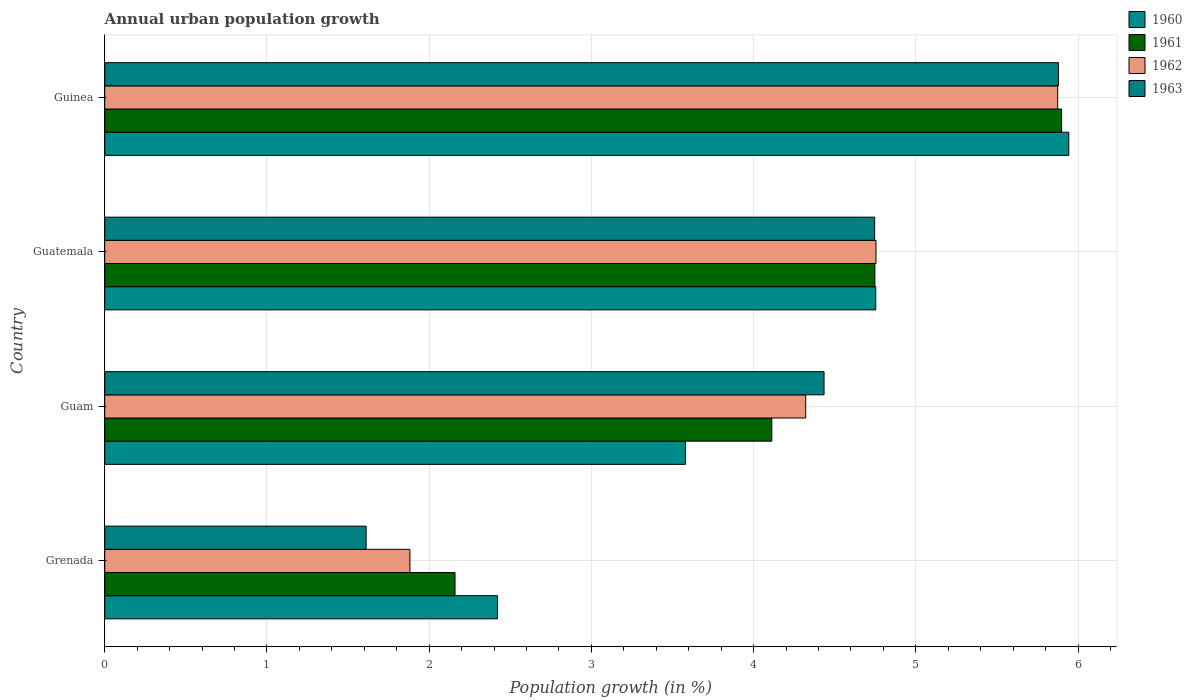How many different coloured bars are there?
Make the answer very short. 4. How many groups of bars are there?
Offer a very short reply. 4. Are the number of bars on each tick of the Y-axis equal?
Your response must be concise. Yes. How many bars are there on the 4th tick from the bottom?
Ensure brevity in your answer.  4. What is the label of the 2nd group of bars from the top?
Your answer should be compact. Guatemala. In how many cases, is the number of bars for a given country not equal to the number of legend labels?
Make the answer very short. 0. What is the percentage of urban population growth in 1963 in Grenada?
Provide a short and direct response. 1.61. Across all countries, what is the maximum percentage of urban population growth in 1960?
Your answer should be very brief. 5.94. Across all countries, what is the minimum percentage of urban population growth in 1960?
Keep it short and to the point. 2.42. In which country was the percentage of urban population growth in 1961 maximum?
Provide a short and direct response. Guinea. In which country was the percentage of urban population growth in 1960 minimum?
Provide a short and direct response. Grenada. What is the total percentage of urban population growth in 1961 in the graph?
Give a very brief answer. 16.92. What is the difference between the percentage of urban population growth in 1963 in Grenada and that in Guatemala?
Provide a succinct answer. -3.13. What is the difference between the percentage of urban population growth in 1963 in Grenada and the percentage of urban population growth in 1961 in Guam?
Ensure brevity in your answer.  -2.5. What is the average percentage of urban population growth in 1961 per country?
Keep it short and to the point. 4.23. What is the difference between the percentage of urban population growth in 1960 and percentage of urban population growth in 1961 in Guam?
Your answer should be very brief. -0.53. In how many countries, is the percentage of urban population growth in 1962 greater than 1.2 %?
Keep it short and to the point. 4. What is the ratio of the percentage of urban population growth in 1963 in Guam to that in Guinea?
Provide a short and direct response. 0.75. What is the difference between the highest and the second highest percentage of urban population growth in 1963?
Ensure brevity in your answer.  1.13. What is the difference between the highest and the lowest percentage of urban population growth in 1960?
Your answer should be very brief. 3.52. In how many countries, is the percentage of urban population growth in 1962 greater than the average percentage of urban population growth in 1962 taken over all countries?
Your response must be concise. 3. Is it the case that in every country, the sum of the percentage of urban population growth in 1960 and percentage of urban population growth in 1962 is greater than the sum of percentage of urban population growth in 1961 and percentage of urban population growth in 1963?
Make the answer very short. No. What does the 4th bar from the top in Guam represents?
Provide a short and direct response. 1960. Is it the case that in every country, the sum of the percentage of urban population growth in 1962 and percentage of urban population growth in 1960 is greater than the percentage of urban population growth in 1961?
Provide a short and direct response. Yes. How many bars are there?
Your answer should be very brief. 16. Are all the bars in the graph horizontal?
Keep it short and to the point. Yes. What is the difference between two consecutive major ticks on the X-axis?
Your answer should be compact. 1. Does the graph contain any zero values?
Your response must be concise. No. Does the graph contain grids?
Make the answer very short. Yes. What is the title of the graph?
Your response must be concise. Annual urban population growth. What is the label or title of the X-axis?
Your answer should be very brief. Population growth (in %). What is the label or title of the Y-axis?
Provide a short and direct response. Country. What is the Population growth (in %) in 1960 in Grenada?
Provide a short and direct response. 2.42. What is the Population growth (in %) of 1961 in Grenada?
Offer a terse response. 2.16. What is the Population growth (in %) of 1962 in Grenada?
Your answer should be very brief. 1.88. What is the Population growth (in %) in 1963 in Grenada?
Your answer should be very brief. 1.61. What is the Population growth (in %) of 1960 in Guam?
Provide a succinct answer. 3.58. What is the Population growth (in %) of 1961 in Guam?
Your answer should be compact. 4.11. What is the Population growth (in %) of 1962 in Guam?
Your answer should be very brief. 4.32. What is the Population growth (in %) in 1963 in Guam?
Your answer should be very brief. 4.43. What is the Population growth (in %) in 1960 in Guatemala?
Provide a short and direct response. 4.75. What is the Population growth (in %) in 1961 in Guatemala?
Give a very brief answer. 4.75. What is the Population growth (in %) of 1962 in Guatemala?
Give a very brief answer. 4.75. What is the Population growth (in %) of 1963 in Guatemala?
Offer a terse response. 4.75. What is the Population growth (in %) in 1960 in Guinea?
Offer a very short reply. 5.94. What is the Population growth (in %) in 1961 in Guinea?
Provide a succinct answer. 5.9. What is the Population growth (in %) in 1962 in Guinea?
Provide a succinct answer. 5.87. What is the Population growth (in %) in 1963 in Guinea?
Ensure brevity in your answer.  5.88. Across all countries, what is the maximum Population growth (in %) of 1960?
Make the answer very short. 5.94. Across all countries, what is the maximum Population growth (in %) of 1961?
Offer a very short reply. 5.9. Across all countries, what is the maximum Population growth (in %) in 1962?
Provide a short and direct response. 5.87. Across all countries, what is the maximum Population growth (in %) in 1963?
Your response must be concise. 5.88. Across all countries, what is the minimum Population growth (in %) in 1960?
Make the answer very short. 2.42. Across all countries, what is the minimum Population growth (in %) in 1961?
Offer a very short reply. 2.16. Across all countries, what is the minimum Population growth (in %) of 1962?
Offer a terse response. 1.88. Across all countries, what is the minimum Population growth (in %) of 1963?
Provide a succinct answer. 1.61. What is the total Population growth (in %) in 1960 in the graph?
Ensure brevity in your answer.  16.7. What is the total Population growth (in %) of 1961 in the graph?
Ensure brevity in your answer.  16.92. What is the total Population growth (in %) in 1962 in the graph?
Offer a very short reply. 16.83. What is the total Population growth (in %) in 1963 in the graph?
Offer a very short reply. 16.67. What is the difference between the Population growth (in %) of 1960 in Grenada and that in Guam?
Your answer should be very brief. -1.16. What is the difference between the Population growth (in %) in 1961 in Grenada and that in Guam?
Your response must be concise. -1.95. What is the difference between the Population growth (in %) in 1962 in Grenada and that in Guam?
Your response must be concise. -2.44. What is the difference between the Population growth (in %) in 1963 in Grenada and that in Guam?
Your answer should be compact. -2.82. What is the difference between the Population growth (in %) in 1960 in Grenada and that in Guatemala?
Your response must be concise. -2.33. What is the difference between the Population growth (in %) of 1961 in Grenada and that in Guatemala?
Your response must be concise. -2.59. What is the difference between the Population growth (in %) in 1962 in Grenada and that in Guatemala?
Make the answer very short. -2.87. What is the difference between the Population growth (in %) in 1963 in Grenada and that in Guatemala?
Your answer should be very brief. -3.13. What is the difference between the Population growth (in %) in 1960 in Grenada and that in Guinea?
Offer a terse response. -3.52. What is the difference between the Population growth (in %) in 1961 in Grenada and that in Guinea?
Your answer should be compact. -3.74. What is the difference between the Population growth (in %) in 1962 in Grenada and that in Guinea?
Give a very brief answer. -3.99. What is the difference between the Population growth (in %) of 1963 in Grenada and that in Guinea?
Provide a succinct answer. -4.27. What is the difference between the Population growth (in %) in 1960 in Guam and that in Guatemala?
Give a very brief answer. -1.17. What is the difference between the Population growth (in %) in 1961 in Guam and that in Guatemala?
Provide a succinct answer. -0.64. What is the difference between the Population growth (in %) in 1962 in Guam and that in Guatemala?
Your response must be concise. -0.43. What is the difference between the Population growth (in %) of 1963 in Guam and that in Guatemala?
Offer a very short reply. -0.31. What is the difference between the Population growth (in %) of 1960 in Guam and that in Guinea?
Your answer should be very brief. -2.36. What is the difference between the Population growth (in %) of 1961 in Guam and that in Guinea?
Your answer should be very brief. -1.79. What is the difference between the Population growth (in %) of 1962 in Guam and that in Guinea?
Your answer should be very brief. -1.55. What is the difference between the Population growth (in %) of 1963 in Guam and that in Guinea?
Ensure brevity in your answer.  -1.44. What is the difference between the Population growth (in %) in 1960 in Guatemala and that in Guinea?
Give a very brief answer. -1.19. What is the difference between the Population growth (in %) in 1961 in Guatemala and that in Guinea?
Ensure brevity in your answer.  -1.15. What is the difference between the Population growth (in %) of 1962 in Guatemala and that in Guinea?
Make the answer very short. -1.12. What is the difference between the Population growth (in %) of 1963 in Guatemala and that in Guinea?
Keep it short and to the point. -1.13. What is the difference between the Population growth (in %) in 1960 in Grenada and the Population growth (in %) in 1961 in Guam?
Make the answer very short. -1.69. What is the difference between the Population growth (in %) in 1960 in Grenada and the Population growth (in %) in 1962 in Guam?
Provide a succinct answer. -1.9. What is the difference between the Population growth (in %) of 1960 in Grenada and the Population growth (in %) of 1963 in Guam?
Keep it short and to the point. -2.01. What is the difference between the Population growth (in %) in 1961 in Grenada and the Population growth (in %) in 1962 in Guam?
Give a very brief answer. -2.16. What is the difference between the Population growth (in %) in 1961 in Grenada and the Population growth (in %) in 1963 in Guam?
Your response must be concise. -2.27. What is the difference between the Population growth (in %) in 1962 in Grenada and the Population growth (in %) in 1963 in Guam?
Offer a terse response. -2.55. What is the difference between the Population growth (in %) in 1960 in Grenada and the Population growth (in %) in 1961 in Guatemala?
Offer a very short reply. -2.33. What is the difference between the Population growth (in %) of 1960 in Grenada and the Population growth (in %) of 1962 in Guatemala?
Make the answer very short. -2.33. What is the difference between the Population growth (in %) of 1960 in Grenada and the Population growth (in %) of 1963 in Guatemala?
Your answer should be very brief. -2.32. What is the difference between the Population growth (in %) of 1961 in Grenada and the Population growth (in %) of 1962 in Guatemala?
Give a very brief answer. -2.59. What is the difference between the Population growth (in %) of 1961 in Grenada and the Population growth (in %) of 1963 in Guatemala?
Provide a short and direct response. -2.59. What is the difference between the Population growth (in %) of 1962 in Grenada and the Population growth (in %) of 1963 in Guatemala?
Your answer should be compact. -2.86. What is the difference between the Population growth (in %) of 1960 in Grenada and the Population growth (in %) of 1961 in Guinea?
Your response must be concise. -3.48. What is the difference between the Population growth (in %) of 1960 in Grenada and the Population growth (in %) of 1962 in Guinea?
Your answer should be very brief. -3.45. What is the difference between the Population growth (in %) of 1960 in Grenada and the Population growth (in %) of 1963 in Guinea?
Offer a very short reply. -3.46. What is the difference between the Population growth (in %) of 1961 in Grenada and the Population growth (in %) of 1962 in Guinea?
Make the answer very short. -3.72. What is the difference between the Population growth (in %) of 1961 in Grenada and the Population growth (in %) of 1963 in Guinea?
Make the answer very short. -3.72. What is the difference between the Population growth (in %) of 1962 in Grenada and the Population growth (in %) of 1963 in Guinea?
Provide a succinct answer. -4. What is the difference between the Population growth (in %) of 1960 in Guam and the Population growth (in %) of 1961 in Guatemala?
Your response must be concise. -1.17. What is the difference between the Population growth (in %) of 1960 in Guam and the Population growth (in %) of 1962 in Guatemala?
Keep it short and to the point. -1.17. What is the difference between the Population growth (in %) of 1960 in Guam and the Population growth (in %) of 1963 in Guatemala?
Your response must be concise. -1.17. What is the difference between the Population growth (in %) of 1961 in Guam and the Population growth (in %) of 1962 in Guatemala?
Make the answer very short. -0.64. What is the difference between the Population growth (in %) of 1961 in Guam and the Population growth (in %) of 1963 in Guatemala?
Your answer should be compact. -0.63. What is the difference between the Population growth (in %) in 1962 in Guam and the Population growth (in %) in 1963 in Guatemala?
Your answer should be very brief. -0.42. What is the difference between the Population growth (in %) in 1960 in Guam and the Population growth (in %) in 1961 in Guinea?
Ensure brevity in your answer.  -2.32. What is the difference between the Population growth (in %) in 1960 in Guam and the Population growth (in %) in 1962 in Guinea?
Give a very brief answer. -2.29. What is the difference between the Population growth (in %) of 1960 in Guam and the Population growth (in %) of 1963 in Guinea?
Your answer should be compact. -2.3. What is the difference between the Population growth (in %) in 1961 in Guam and the Population growth (in %) in 1962 in Guinea?
Offer a very short reply. -1.76. What is the difference between the Population growth (in %) of 1961 in Guam and the Population growth (in %) of 1963 in Guinea?
Your response must be concise. -1.77. What is the difference between the Population growth (in %) of 1962 in Guam and the Population growth (in %) of 1963 in Guinea?
Make the answer very short. -1.56. What is the difference between the Population growth (in %) in 1960 in Guatemala and the Population growth (in %) in 1961 in Guinea?
Your response must be concise. -1.15. What is the difference between the Population growth (in %) of 1960 in Guatemala and the Population growth (in %) of 1962 in Guinea?
Make the answer very short. -1.12. What is the difference between the Population growth (in %) of 1960 in Guatemala and the Population growth (in %) of 1963 in Guinea?
Provide a succinct answer. -1.13. What is the difference between the Population growth (in %) in 1961 in Guatemala and the Population growth (in %) in 1962 in Guinea?
Offer a very short reply. -1.13. What is the difference between the Population growth (in %) in 1961 in Guatemala and the Population growth (in %) in 1963 in Guinea?
Ensure brevity in your answer.  -1.13. What is the difference between the Population growth (in %) in 1962 in Guatemala and the Population growth (in %) in 1963 in Guinea?
Offer a very short reply. -1.12. What is the average Population growth (in %) of 1960 per country?
Your answer should be very brief. 4.17. What is the average Population growth (in %) of 1961 per country?
Give a very brief answer. 4.23. What is the average Population growth (in %) in 1962 per country?
Provide a succinct answer. 4.21. What is the average Population growth (in %) in 1963 per country?
Offer a very short reply. 4.17. What is the difference between the Population growth (in %) in 1960 and Population growth (in %) in 1961 in Grenada?
Ensure brevity in your answer.  0.26. What is the difference between the Population growth (in %) in 1960 and Population growth (in %) in 1962 in Grenada?
Provide a short and direct response. 0.54. What is the difference between the Population growth (in %) of 1960 and Population growth (in %) of 1963 in Grenada?
Keep it short and to the point. 0.81. What is the difference between the Population growth (in %) in 1961 and Population growth (in %) in 1962 in Grenada?
Your answer should be compact. 0.28. What is the difference between the Population growth (in %) in 1961 and Population growth (in %) in 1963 in Grenada?
Ensure brevity in your answer.  0.55. What is the difference between the Population growth (in %) of 1962 and Population growth (in %) of 1963 in Grenada?
Keep it short and to the point. 0.27. What is the difference between the Population growth (in %) in 1960 and Population growth (in %) in 1961 in Guam?
Your answer should be very brief. -0.53. What is the difference between the Population growth (in %) of 1960 and Population growth (in %) of 1962 in Guam?
Give a very brief answer. -0.74. What is the difference between the Population growth (in %) in 1960 and Population growth (in %) in 1963 in Guam?
Your response must be concise. -0.85. What is the difference between the Population growth (in %) of 1961 and Population growth (in %) of 1962 in Guam?
Give a very brief answer. -0.21. What is the difference between the Population growth (in %) of 1961 and Population growth (in %) of 1963 in Guam?
Ensure brevity in your answer.  -0.32. What is the difference between the Population growth (in %) of 1962 and Population growth (in %) of 1963 in Guam?
Provide a short and direct response. -0.11. What is the difference between the Population growth (in %) in 1960 and Population growth (in %) in 1961 in Guatemala?
Provide a succinct answer. 0.01. What is the difference between the Population growth (in %) of 1960 and Population growth (in %) of 1962 in Guatemala?
Ensure brevity in your answer.  -0. What is the difference between the Population growth (in %) of 1960 and Population growth (in %) of 1963 in Guatemala?
Ensure brevity in your answer.  0.01. What is the difference between the Population growth (in %) of 1961 and Population growth (in %) of 1962 in Guatemala?
Ensure brevity in your answer.  -0.01. What is the difference between the Population growth (in %) in 1961 and Population growth (in %) in 1963 in Guatemala?
Keep it short and to the point. 0. What is the difference between the Population growth (in %) of 1962 and Population growth (in %) of 1963 in Guatemala?
Your answer should be compact. 0.01. What is the difference between the Population growth (in %) of 1960 and Population growth (in %) of 1961 in Guinea?
Provide a succinct answer. 0.04. What is the difference between the Population growth (in %) of 1960 and Population growth (in %) of 1962 in Guinea?
Provide a succinct answer. 0.07. What is the difference between the Population growth (in %) of 1960 and Population growth (in %) of 1963 in Guinea?
Give a very brief answer. 0.06. What is the difference between the Population growth (in %) in 1961 and Population growth (in %) in 1962 in Guinea?
Give a very brief answer. 0.02. What is the difference between the Population growth (in %) of 1961 and Population growth (in %) of 1963 in Guinea?
Make the answer very short. 0.02. What is the difference between the Population growth (in %) in 1962 and Population growth (in %) in 1963 in Guinea?
Provide a succinct answer. -0. What is the ratio of the Population growth (in %) of 1960 in Grenada to that in Guam?
Your answer should be very brief. 0.68. What is the ratio of the Population growth (in %) in 1961 in Grenada to that in Guam?
Give a very brief answer. 0.53. What is the ratio of the Population growth (in %) in 1962 in Grenada to that in Guam?
Give a very brief answer. 0.44. What is the ratio of the Population growth (in %) of 1963 in Grenada to that in Guam?
Ensure brevity in your answer.  0.36. What is the ratio of the Population growth (in %) of 1960 in Grenada to that in Guatemala?
Make the answer very short. 0.51. What is the ratio of the Population growth (in %) of 1961 in Grenada to that in Guatemala?
Your response must be concise. 0.45. What is the ratio of the Population growth (in %) in 1962 in Grenada to that in Guatemala?
Give a very brief answer. 0.4. What is the ratio of the Population growth (in %) of 1963 in Grenada to that in Guatemala?
Provide a succinct answer. 0.34. What is the ratio of the Population growth (in %) in 1960 in Grenada to that in Guinea?
Offer a terse response. 0.41. What is the ratio of the Population growth (in %) of 1961 in Grenada to that in Guinea?
Your answer should be very brief. 0.37. What is the ratio of the Population growth (in %) in 1962 in Grenada to that in Guinea?
Offer a terse response. 0.32. What is the ratio of the Population growth (in %) in 1963 in Grenada to that in Guinea?
Offer a very short reply. 0.27. What is the ratio of the Population growth (in %) of 1960 in Guam to that in Guatemala?
Your answer should be very brief. 0.75. What is the ratio of the Population growth (in %) in 1961 in Guam to that in Guatemala?
Your answer should be compact. 0.87. What is the ratio of the Population growth (in %) in 1962 in Guam to that in Guatemala?
Make the answer very short. 0.91. What is the ratio of the Population growth (in %) of 1963 in Guam to that in Guatemala?
Ensure brevity in your answer.  0.93. What is the ratio of the Population growth (in %) in 1960 in Guam to that in Guinea?
Offer a terse response. 0.6. What is the ratio of the Population growth (in %) in 1961 in Guam to that in Guinea?
Keep it short and to the point. 0.7. What is the ratio of the Population growth (in %) of 1962 in Guam to that in Guinea?
Make the answer very short. 0.74. What is the ratio of the Population growth (in %) of 1963 in Guam to that in Guinea?
Your answer should be compact. 0.75. What is the ratio of the Population growth (in %) of 1960 in Guatemala to that in Guinea?
Offer a very short reply. 0.8. What is the ratio of the Population growth (in %) in 1961 in Guatemala to that in Guinea?
Keep it short and to the point. 0.8. What is the ratio of the Population growth (in %) of 1962 in Guatemala to that in Guinea?
Give a very brief answer. 0.81. What is the ratio of the Population growth (in %) in 1963 in Guatemala to that in Guinea?
Offer a very short reply. 0.81. What is the difference between the highest and the second highest Population growth (in %) of 1960?
Your answer should be compact. 1.19. What is the difference between the highest and the second highest Population growth (in %) in 1961?
Offer a very short reply. 1.15. What is the difference between the highest and the second highest Population growth (in %) in 1962?
Offer a very short reply. 1.12. What is the difference between the highest and the second highest Population growth (in %) of 1963?
Your answer should be compact. 1.13. What is the difference between the highest and the lowest Population growth (in %) in 1960?
Your answer should be compact. 3.52. What is the difference between the highest and the lowest Population growth (in %) of 1961?
Your answer should be compact. 3.74. What is the difference between the highest and the lowest Population growth (in %) in 1962?
Make the answer very short. 3.99. What is the difference between the highest and the lowest Population growth (in %) in 1963?
Your response must be concise. 4.27. 